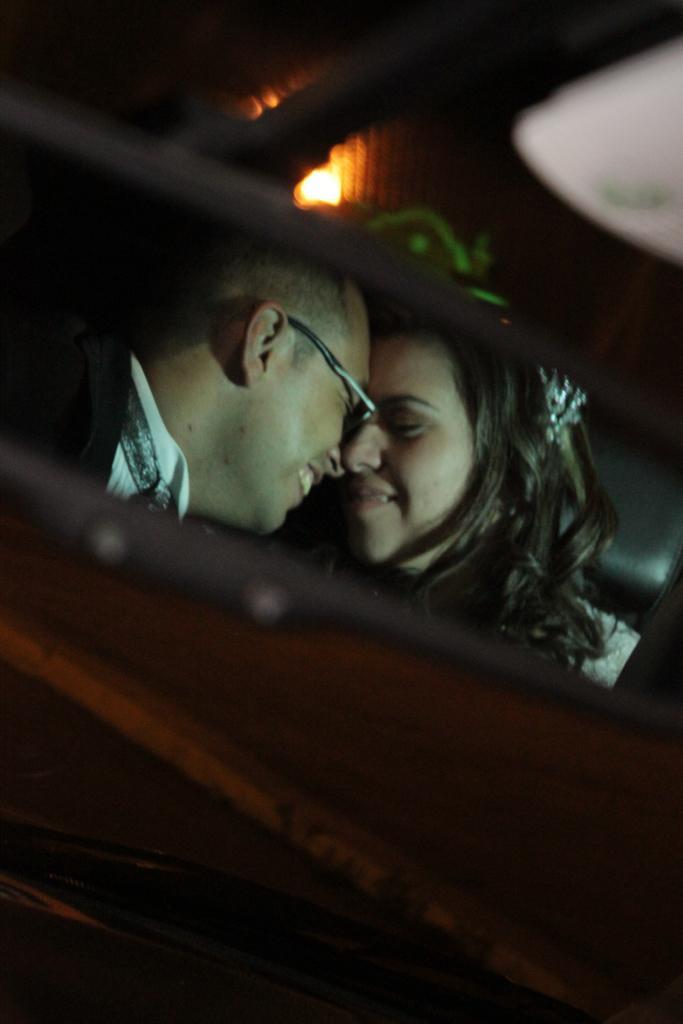How would you summarize this image in a sentence or two? In this picture we can see two people smiling, light, some objects and in the background it is dark. 